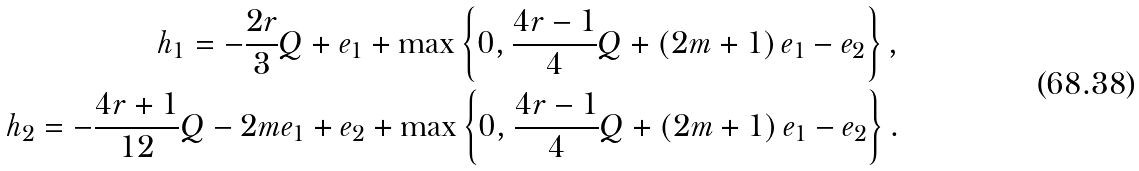Convert formula to latex. <formula><loc_0><loc_0><loc_500><loc_500>h _ { 1 } = - \frac { 2 r } { 3 } Q + e _ { 1 } + \max \left \{ 0 , \frac { 4 r - 1 } { 4 } Q + \left ( 2 m + 1 \right ) e _ { 1 } - e _ { 2 } \right \} , \\ h _ { 2 } = - \frac { 4 r + 1 } { 1 2 } Q - 2 m e _ { 1 } + e _ { 2 } + \max \left \{ 0 , \frac { 4 r - 1 } { 4 } Q + \left ( 2 m + 1 \right ) e _ { 1 } - e _ { 2 } \right \} .</formula> 